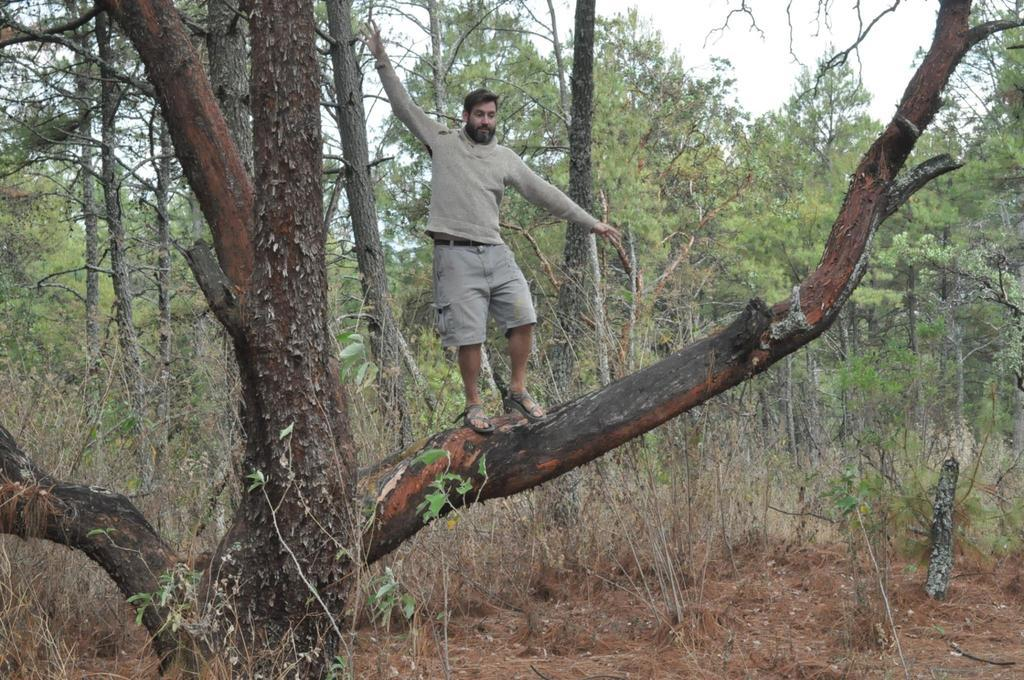What is the main subject of the image? There is a person in the image. Where is the person located? The person is on a tree. What else can be seen in the image besides the person? There are trees in the middle of the image. What type of chicken can be seen in the image? There is no chicken present in the image; it features a person on a tree and trees in the middle. How many pickles are visible in the image? There are no pickles present in the image. 